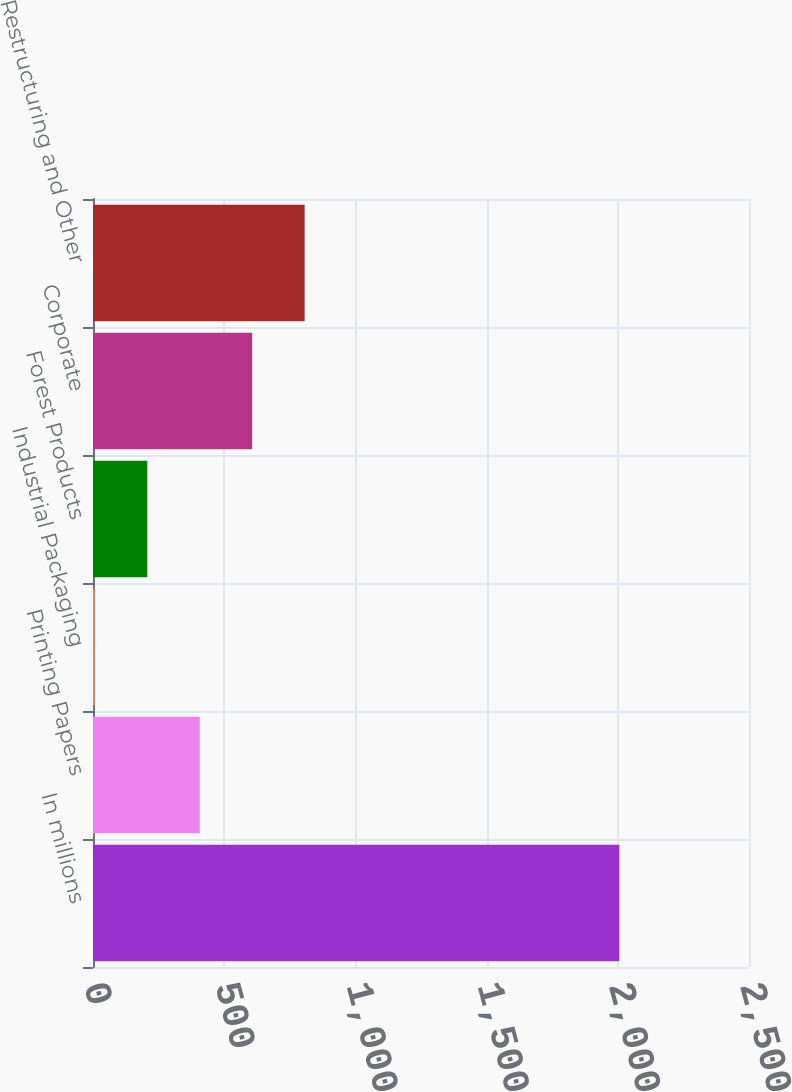<chart> <loc_0><loc_0><loc_500><loc_500><bar_chart><fcel>In millions<fcel>Printing Papers<fcel>Industrial Packaging<fcel>Forest Products<fcel>Corporate<fcel>Restructuring and Other<nl><fcel>2006<fcel>406.8<fcel>7<fcel>206.9<fcel>606.7<fcel>806.6<nl></chart> 